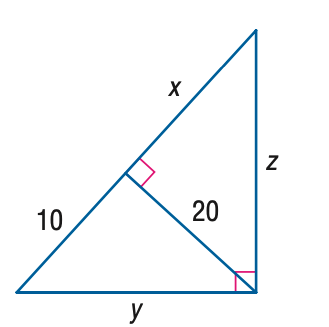Answer the mathemtical geometry problem and directly provide the correct option letter.
Question: Find z.
Choices: A: 20 B: 20 \sqrt { 3 } C: 40 D: 20 \sqrt { 5 } D 